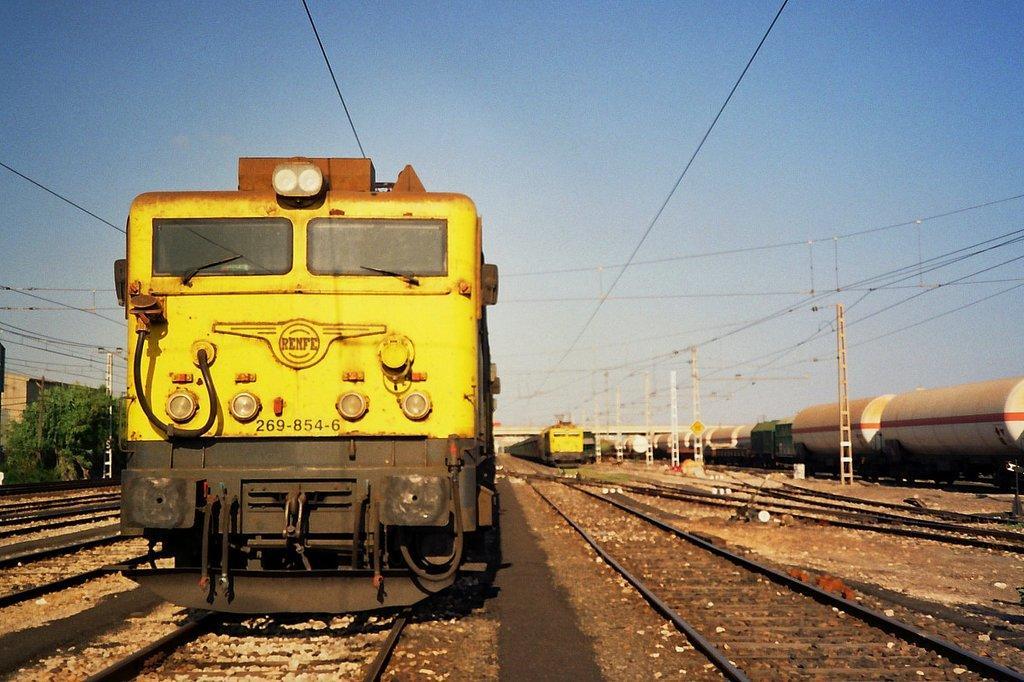In one or two sentences, can you explain what this image depicts? In the picture I can see few trains are moving on the track, side we can see some trees and building. 